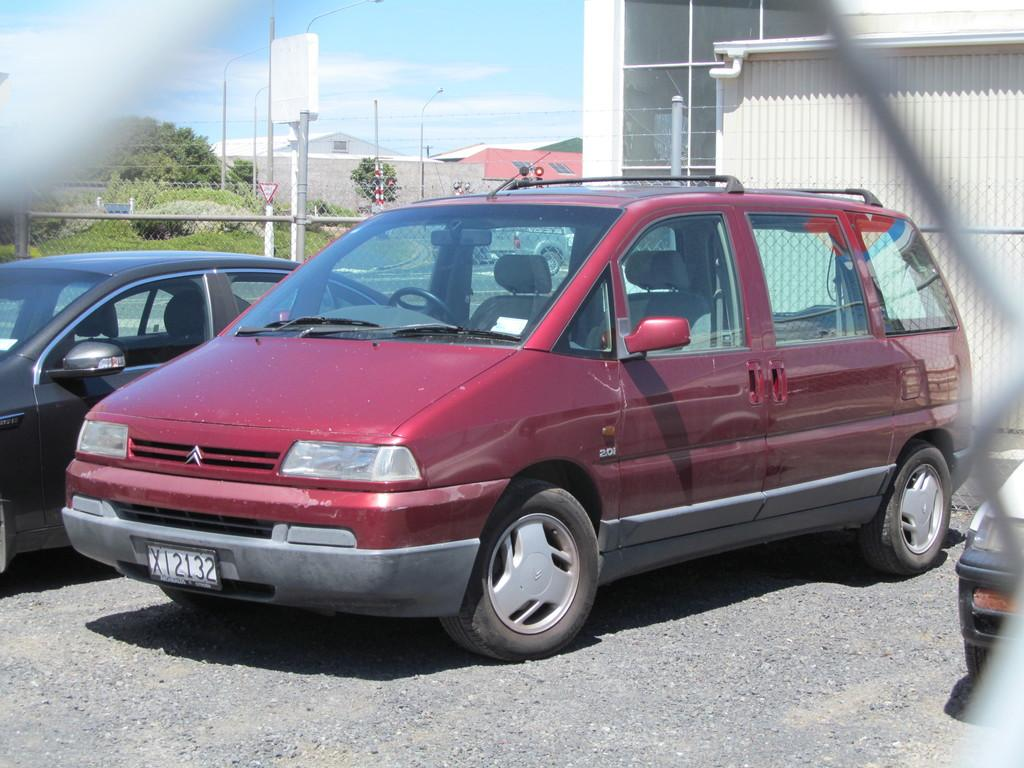What types of objects can be seen in the image? There are vehicles, poles, lights, a fence, sheds, plants, and trees in the image. Can you describe the structures in the image? There are sheds and a fence visible in the image. What type of vegetation is present in the image? There are plants and trees in the image. What is visible in the background of the image? The sky is visible in the background of the image. What type of wound can be seen on the tree in the image? There is no wound present on the tree in the image. What type of pleasure can be seen in the image? There is no indication of pleasure in the image; it features various objects and structures. 